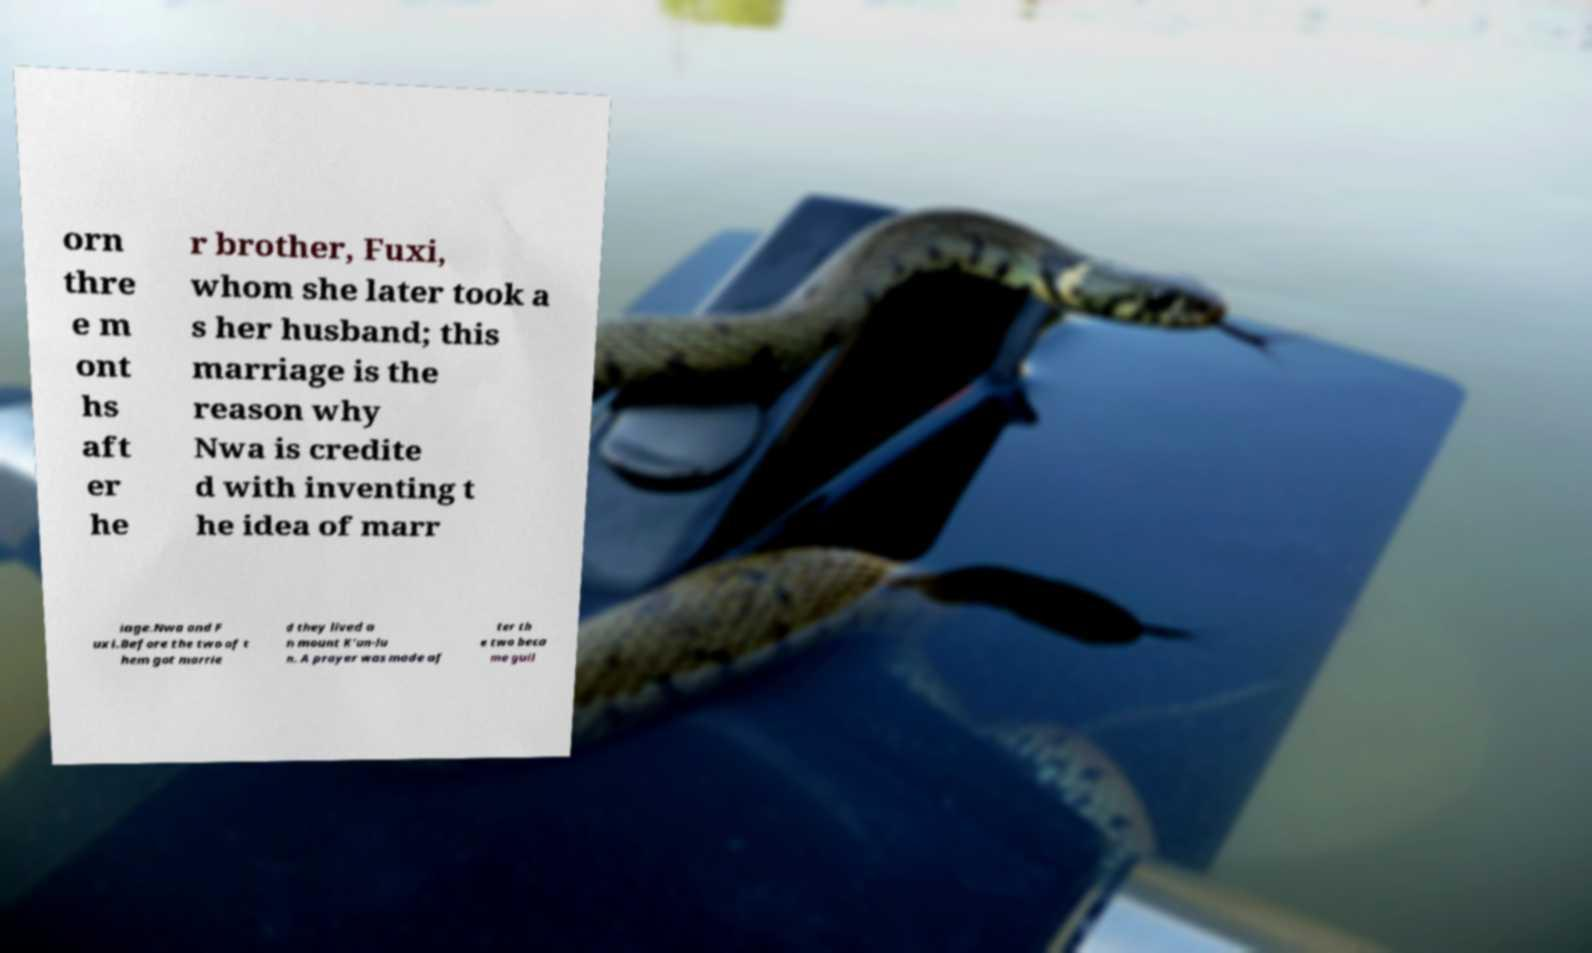Please identify and transcribe the text found in this image. orn thre e m ont hs aft er he r brother, Fuxi, whom she later took a s her husband; this marriage is the reason why Nwa is credite d with inventing t he idea of marr iage.Nwa and F uxi.Before the two of t hem got marrie d they lived o n mount K'un-lu n. A prayer was made af ter th e two beca me guil 